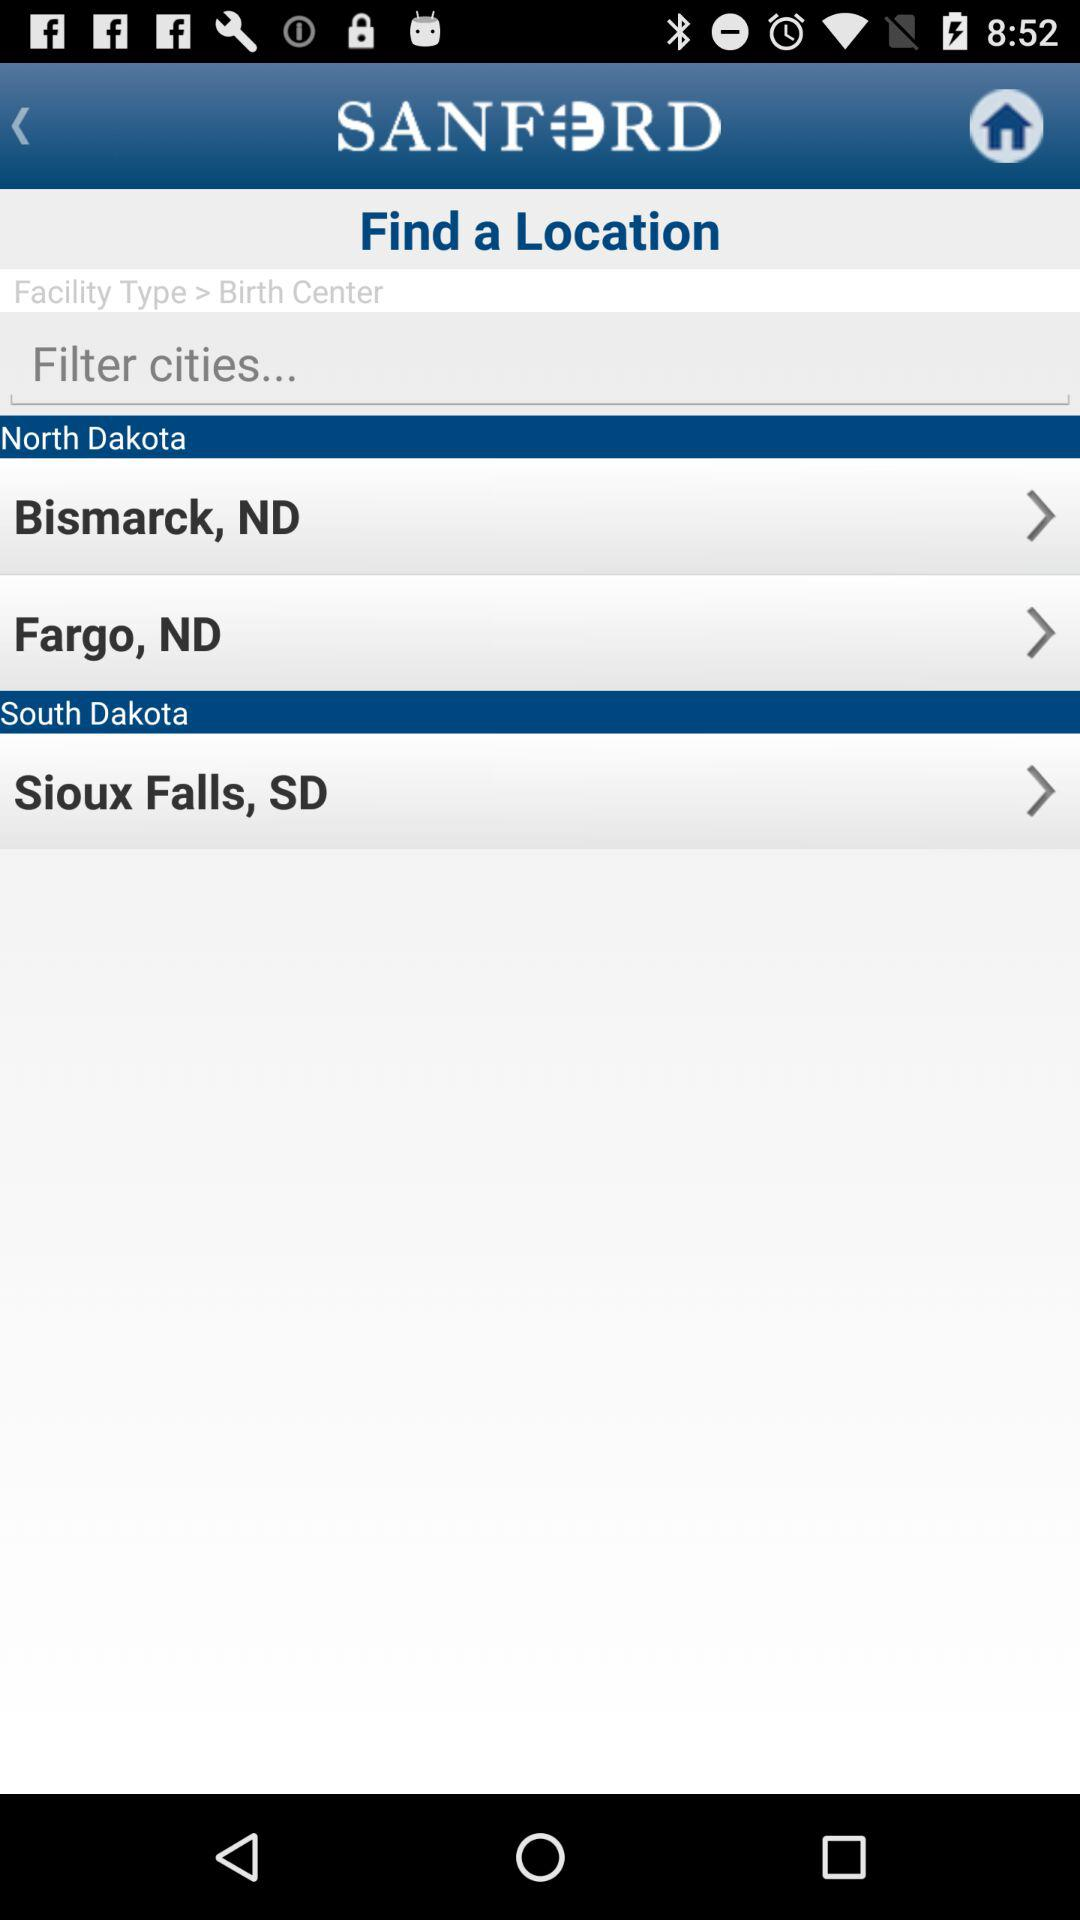What is the application name? The application name is "SANFORD". 